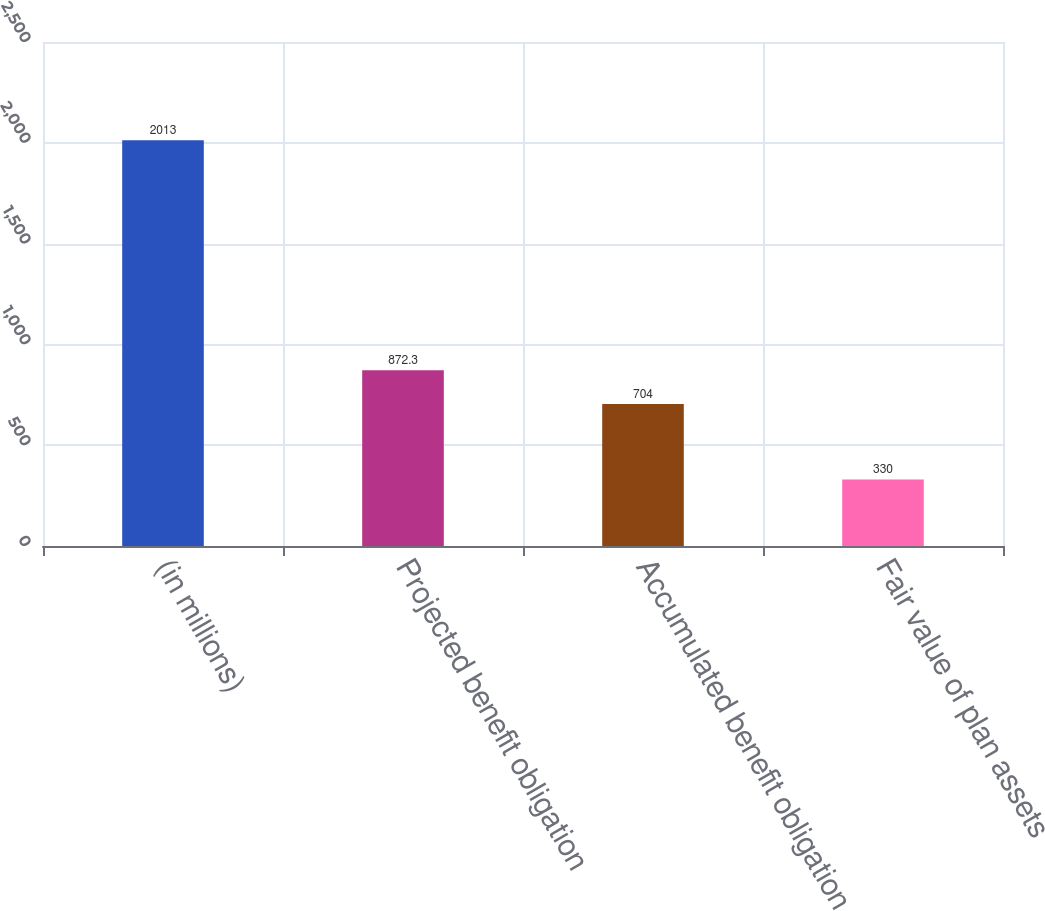Convert chart. <chart><loc_0><loc_0><loc_500><loc_500><bar_chart><fcel>(in millions)<fcel>Projected benefit obligation<fcel>Accumulated benefit obligation<fcel>Fair value of plan assets<nl><fcel>2013<fcel>872.3<fcel>704<fcel>330<nl></chart> 